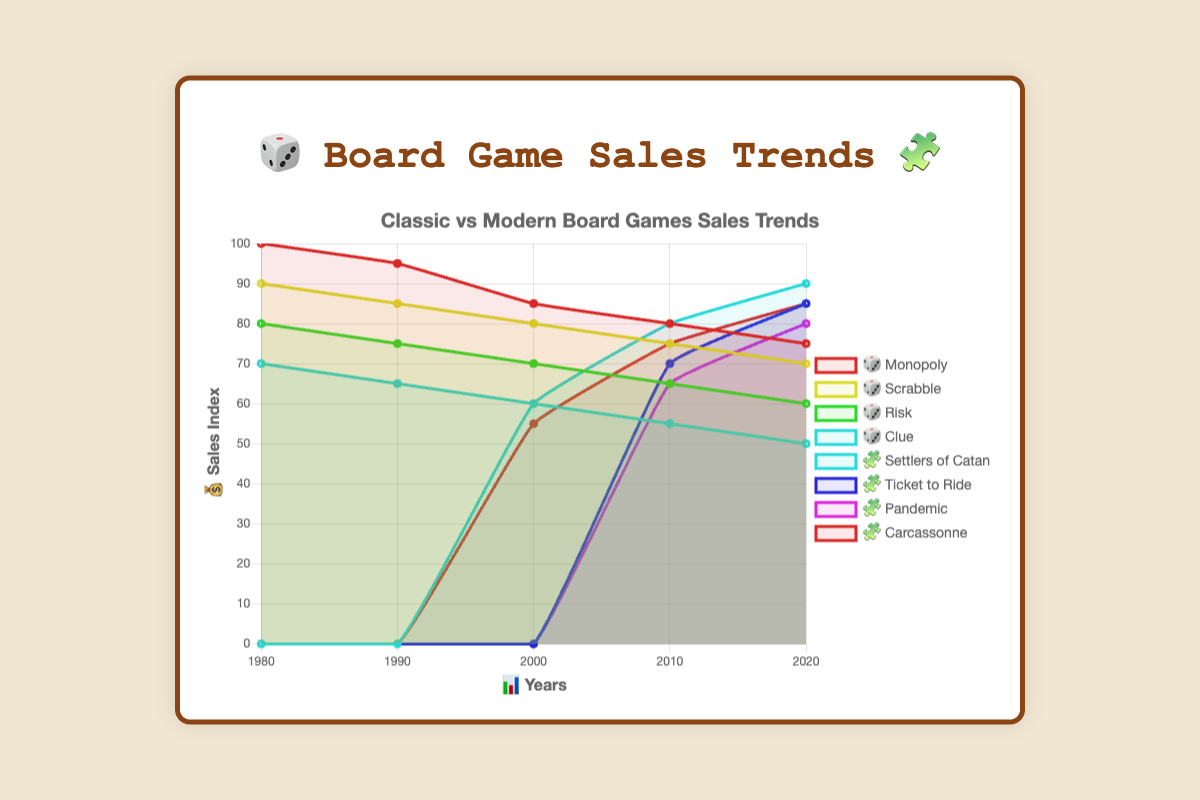What are the sales trends for "Monopoly" from 1980 to 2020? The sales for "Monopoly" decrease over the years. From 100 in 1980 to 75 in 2020, the data points are: 100 (1980), 95 (1990), 85 (2000), 80 (2010), 75 (2020).
Answer: Decreasing Which modern board game had zero sales in 2000? By looking at the figure, all modern board games (Settlers of Catan, Ticket to Ride, Pandemic, and Carcassonne) had zero sales in 2000.
Answer: All Comparing "Pandemic" and "Risk" in 2020, which game had higher sales? In 2020, "Pandemic" had a sales index of 80, whereas "Risk" had a sales index of 60, making "Pandemic" the one with higher sales.
Answer: Pandemic What's the total sales index for "Clue" from 1980 to 2020? Sum the sales indexes of Clue over the years: 70 (1980) + 65 (1990) + 60 (2000) + 55 (2010) + 50 (2020). The total is 70 + 65 + 60 + 55 + 50 = 300.
Answer: 300 Which classic board game experienced the greatest decline in sales from 1980 to 2020? Calculating the decline for each: Monopoly from 100 to 75 (25), Scrabble from 90 to 70 (20), Risk from 80 to 60 (20), Clue from 70 to 50 (20). Monopoly experienced the greatest decline.
Answer: Monopoly Which game had the highest sales index in 2010? In 2010, the highest sales index is from "Monopoly" among classic games and "Settlers of Catan" among modern games. Between them, "Settlers of Catan" has the higher value of 80 compared to 80 of Monopoly.
Answer: Settlers of Catan Between 2000 and 2010, which modern board game saw the biggest increase in sales? Comparing the sales increase in this period for each modern game: Settlers of Catan (20), Ticket to Ride (70), Pandemic (65), Carcassonne (20). Ticket to Ride had the biggest increase.
Answer: Ticket to Ride How do the sales trends of classic and modern board games compare overall? Classic board games generally show a decreasing trend in sales over time, whereas modern board games indicate an increasing trend from around 2000 onwards. This is seen by comparing the slopes of the lines: classic games' lines slope downward, and modern games' lines trend upwards.
Answer: Decreasing vs Increasing 